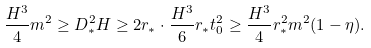<formula> <loc_0><loc_0><loc_500><loc_500>\frac { H ^ { 3 } } { 4 } m ^ { 2 } \geq D _ { \ast } ^ { 2 } H \geq 2 r _ { \ast } \cdot \frac { H ^ { 3 } } { 6 } r _ { \ast } t _ { 0 } ^ { 2 } \geq \frac { H ^ { 3 } } { 4 } r _ { \ast } ^ { 2 } m ^ { 2 } ( 1 - \eta ) .</formula> 